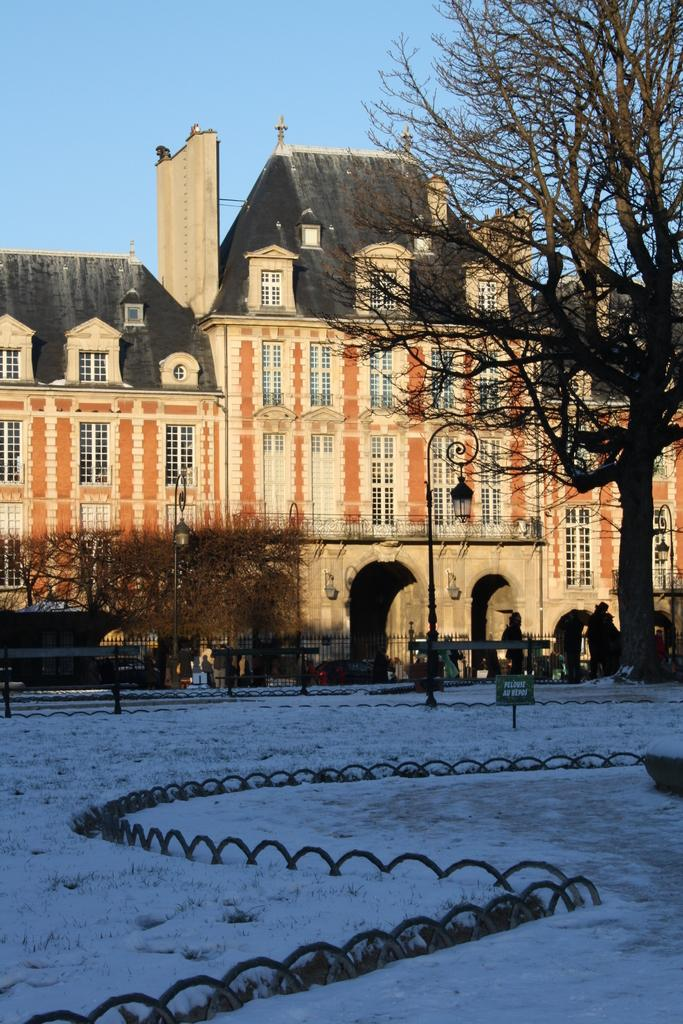What type of structure is present in the image? There is a building in the image. What feature can be observed on the building? The building has windows. What are the light sources in the image? There are light poles in the image. What type of information might be displayed in the image? There is a sign board in the image, which could display information. What is the weather condition in the image? There is snow in the image, indicating a cold or wintry environment. What type of barrier is present in the image? There is fencing in the image. What type of vegetation is present in the image? There are plants and a tree in the image. Are there any people visible in the image? Yes, there are people in the image. What part of the natural environment is visible in the image? The sky is visible in the image. How many forks are being used by the people in the image? There is no mention of forks in the image; they are not present. 